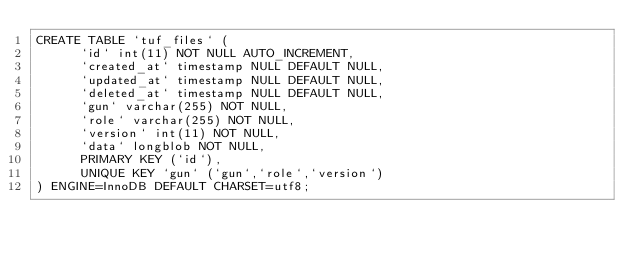<code> <loc_0><loc_0><loc_500><loc_500><_SQL_>CREATE TABLE `tuf_files` (
	  `id` int(11) NOT NULL AUTO_INCREMENT,
	  `created_at` timestamp NULL DEFAULT NULL,
	  `updated_at` timestamp NULL DEFAULT NULL,
	  `deleted_at` timestamp NULL DEFAULT NULL,
	  `gun` varchar(255) NOT NULL,
	  `role` varchar(255) NOT NULL,
	  `version` int(11) NOT NULL,
	  `data` longblob NOT NULL,
	  PRIMARY KEY (`id`),
	  UNIQUE KEY `gun` (`gun`,`role`,`version`)
) ENGINE=InnoDB DEFAULT CHARSET=utf8;
</code> 